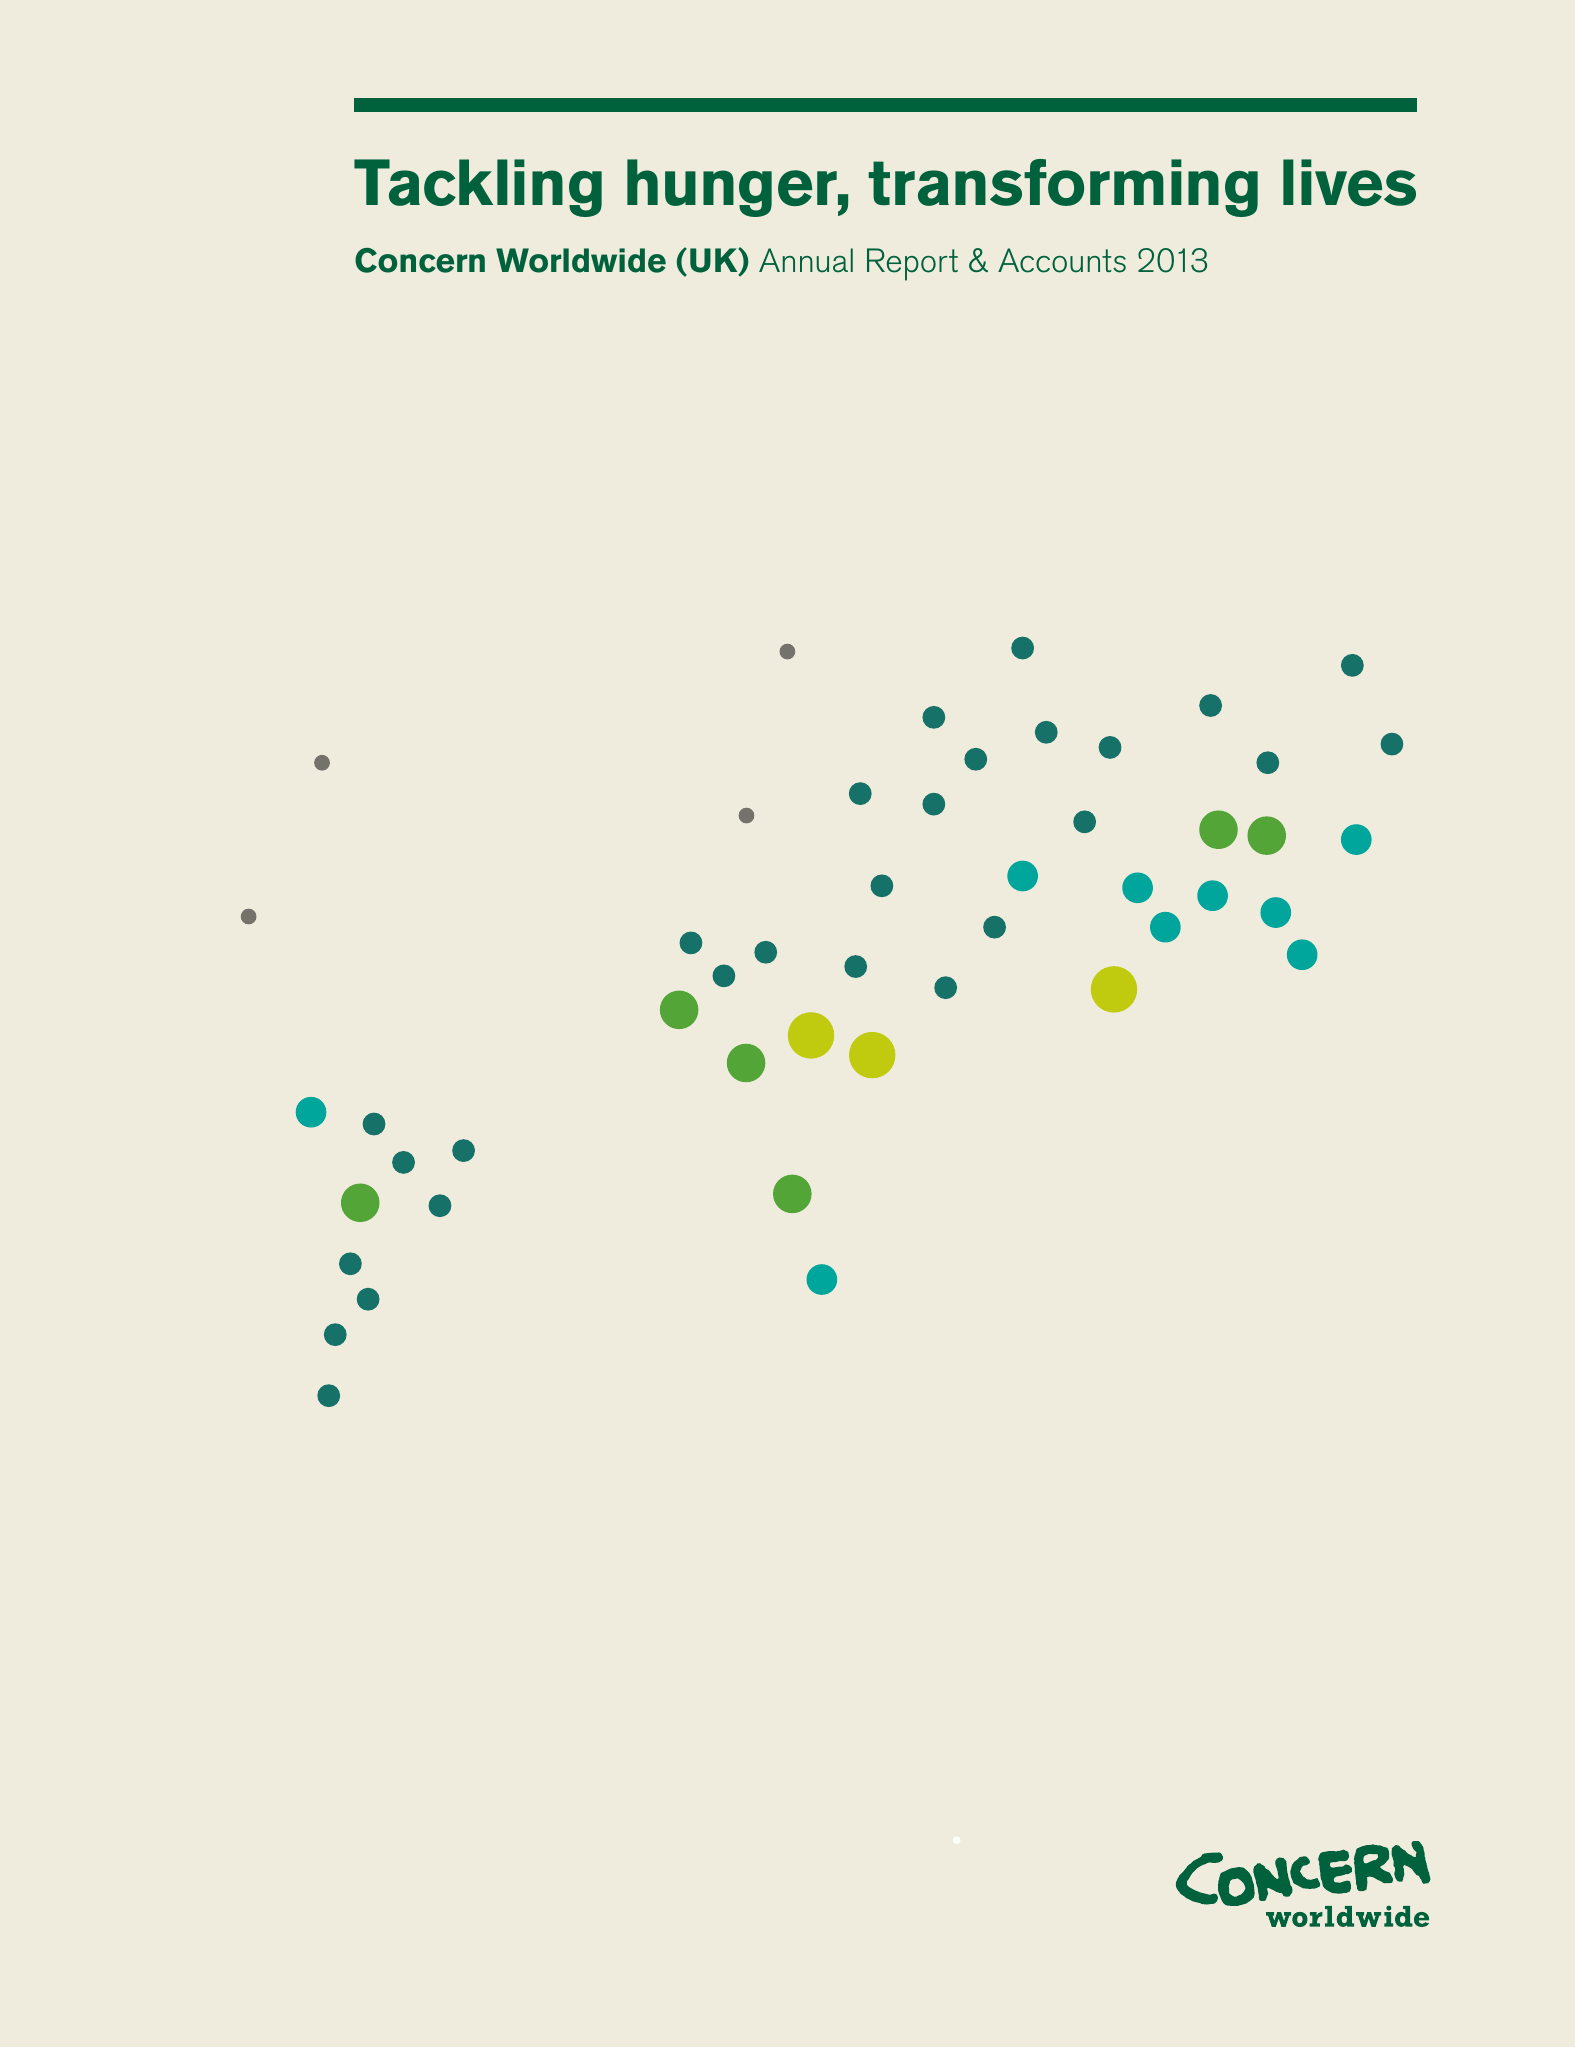What is the value for the address__post_town?
Answer the question using a single word or phrase. LONDON 